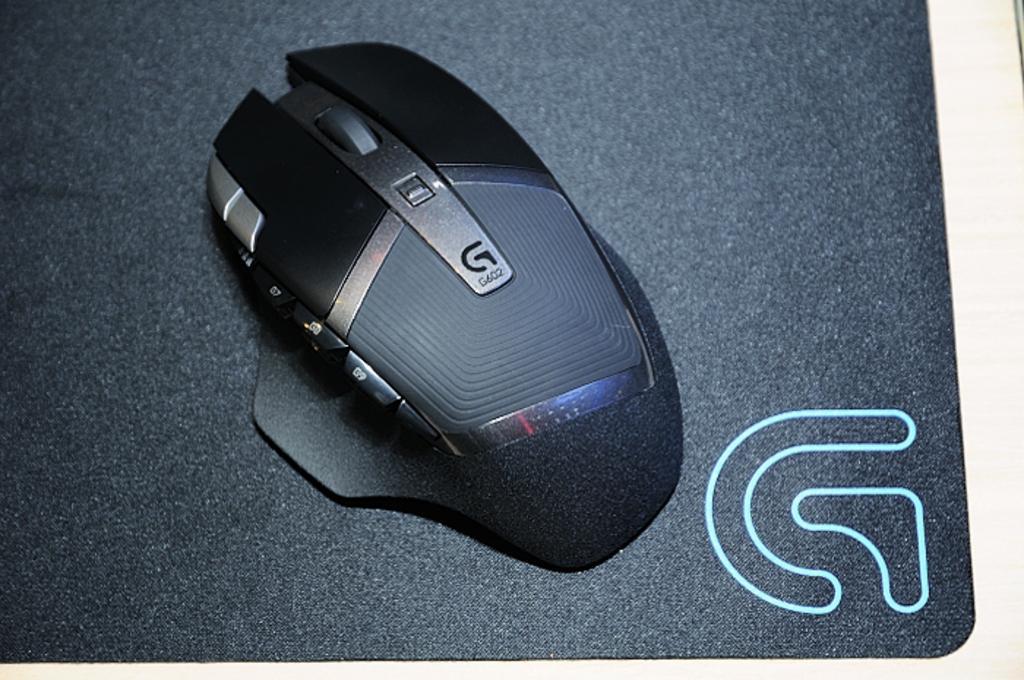Please provide a concise description of this image. In this picture, we can see wireless mouse on an object, and we can see some watermark on the bottom right side of the picture. 